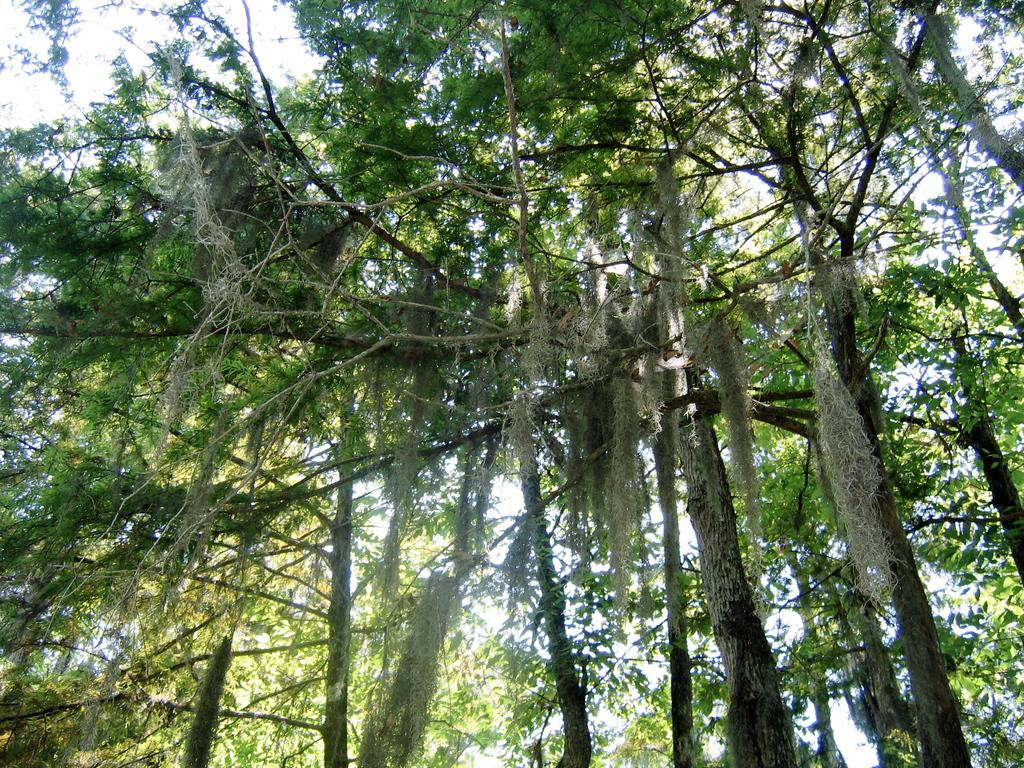What is the primary feature of the image? There are many trees in the image. Can you describe the landscape in the image? The landscape in the image is dominated by trees. Who is the owner of the trees in the image? There is no information about the ownership of the trees in the image. How is the land divided among the trees in the image? There is no information about the division of land among the trees in the image. What type of bubbles can be seen floating among the trees in the image? There are no bubbles present in the image; it features trees in a landscape. 